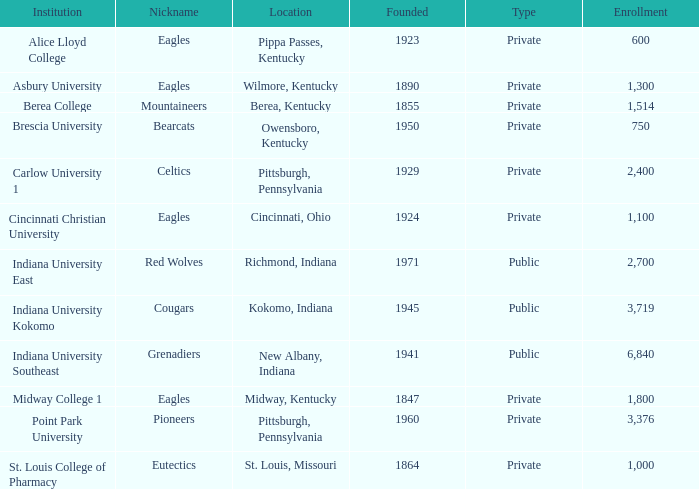Which public college has a nickname of The Grenadiers? Indiana University Southeast. 